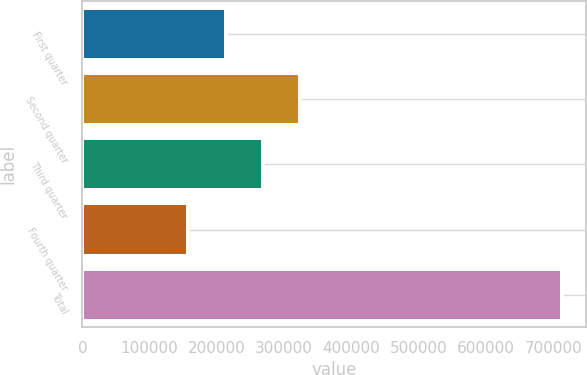Convert chart. <chart><loc_0><loc_0><loc_500><loc_500><bar_chart><fcel>First quarter<fcel>Second quarter<fcel>Third quarter<fcel>Fourth quarter<fcel>Total<nl><fcel>212893<fcel>324132<fcel>268513<fcel>157274<fcel>713468<nl></chart> 